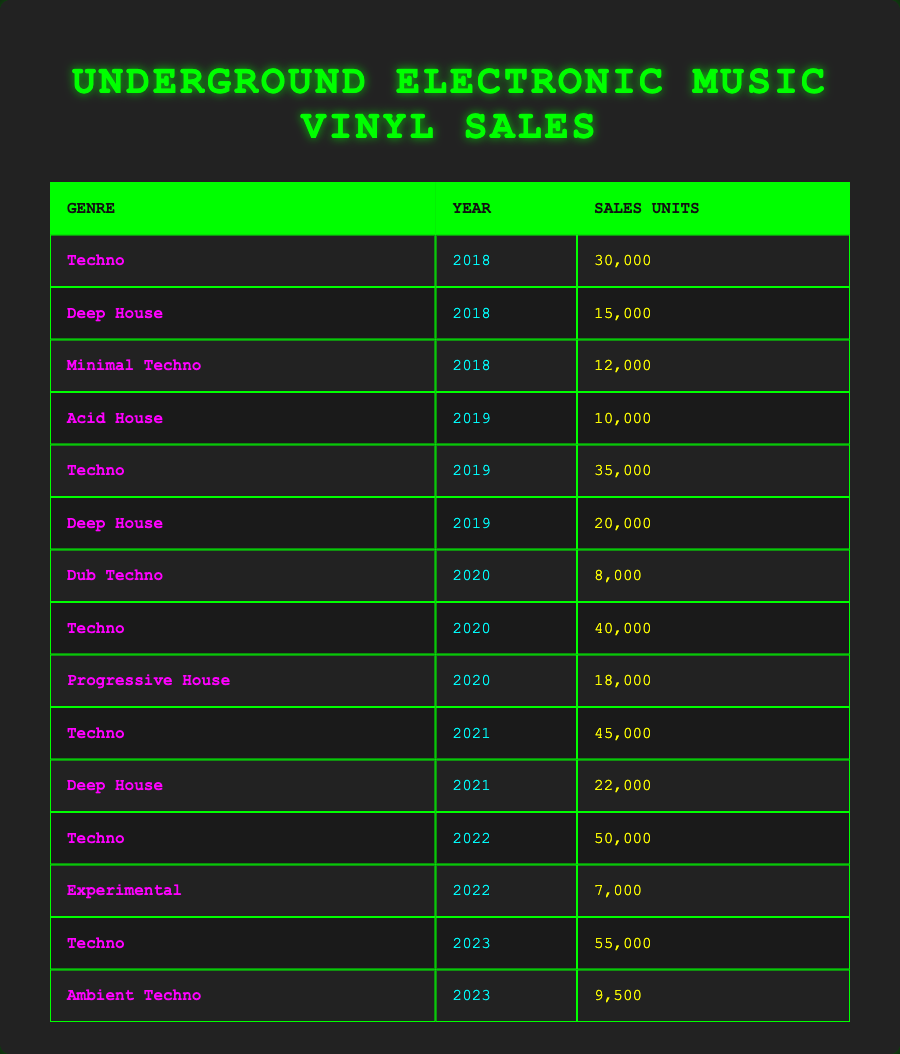What was the total sales of Techno vinyl in 2020? In 2020, the Techno genre had sales of 40,000 units. This is the only entry for Techno in that year, so the total sales for Techno in 2020 is simply 40,000.
Answer: 40,000 Which year saw the highest sales for Deep House? Analyzing the sales units for Deep House across the years, we see 15,000 in 2018, 20,000 in 2019, and 22,000 in 2021. The highest sales for Deep House were in 2021 with 22,000 units.
Answer: 2021 How many more sales units did Techno have in 2023 compared to 2021? Techno sales in 2023 were 55,000, while in 2021 they were 45,000. The difference is calculated as 55,000 - 45,000 = 10,000.
Answer: 10,000 Did Acid House have more sales than Dub Techno in 2020? In 2020, Acid House had no recorded sales, while Dub Techno had sales of 8,000 units. Therefore, Acid House did not have more sales than Dub Techno in that year.
Answer: No What was the average number of vinyl sales for Techno from 2018 to 2022? The sales for Techno from 2018 to 2022 were: 30,000 (2018), 35,000 (2019), 40,000 (2020), 45,000 (2021), and 50,000 (2022). Summing these gives 30,000 + 35,000 + 40,000 + 45,000 + 50,000 = 200,000. Since there are five entries, the average is 200,000 / 5 = 40,000.
Answer: 40,000 In which year did Experimental vinyl sales reach the lowest? The only recorded sales for Experimental were in 2022 with 7,000 units. Since this is the only data point, it represents the lowest sales for Experimental.
Answer: 2022 How many total vinyl sales were there for Deep House across all years? Summing up the Deep House sales: 15,000 (2018), 20,000 (2019), and 22,000 (2021). The total is 15,000 + 20,000 + 22,000 = 57,000.
Answer: 57,000 Which genre had the least sales in 2022 and how many units were sold? In 2022, the sales for Experimental were 7,000 units, while Techno had 50,000 units, indicating that Experimental had the least sales in 2022 with 7,000 units sold.
Answer: 7,000 